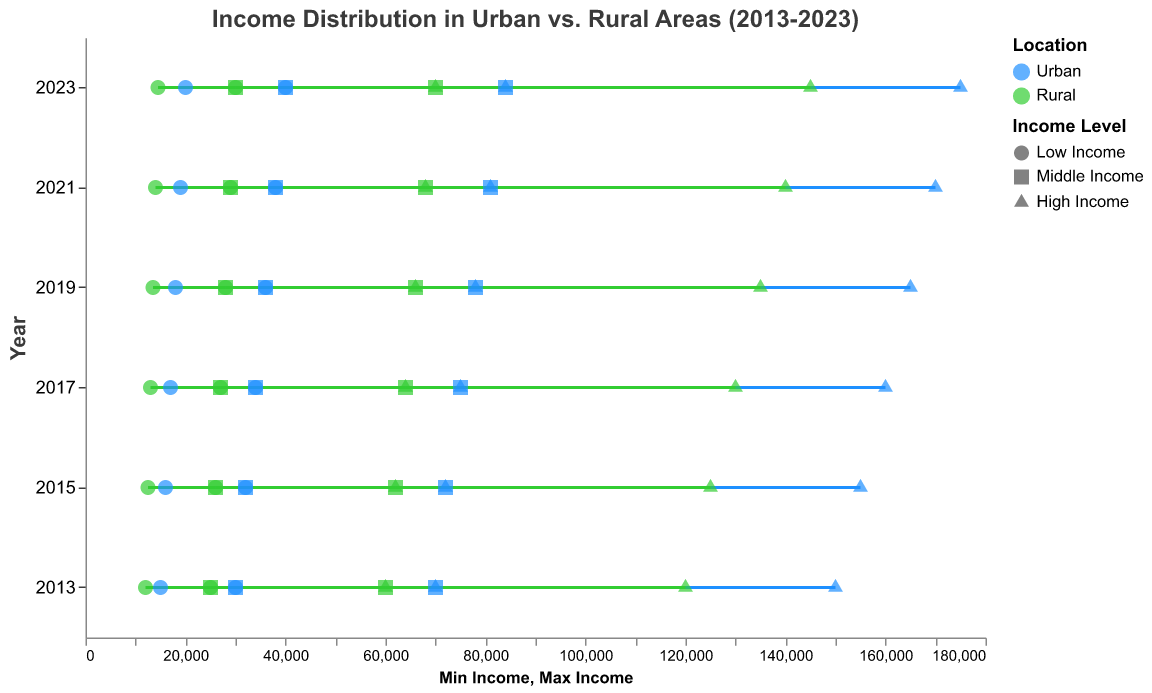What is the title of the figure? The title is located at the top of the chart in a slightly larger font size and reads "Income Distribution in Urban vs. Rural Areas (2013-2023)"
Answer: Income Distribution in Urban vs. Rural Areas (2013-2023) How many years of data are displayed in the figure? Count the distinct years labeled on the vertical axis of the plot, which orders the years in descending order from 2023 to 2013
Answer: 6 For the year 2023, what are the minimum and maximum incomes for the high-income rural area? Locate the year 2023 on the vertical axis, then find the corresponding high-income rural data point. The high-income rural data points are represented by triangles and colored in green. The range is marked by two points on the horizontal axis.
Answer: 70,001 to 145,000 Which location, urban or rural, has a higher maximum income across all years? Compare the maximum income values represented as dots on the far right of the plot. Check both urban (blue) and rural (green) dots in high-income categories.
Answer: Urban How does the income range for middle-income urban areas change from 2013 to 2023? Observe the blue square points at the beginning of each year, detailing the range's minimum and maximum incomes.
Answer: Increases from 30,001-70,000 to 40,001-84,000 Which has a greater increase over time for middle-income levels, urban or rural areas? For each year, identify the income range for middle-income levels in both urban (blue square) and rural (green square). Measure the difference in min and max values from 2013 to 2023 for both locations. Urban: (84,000 - 70,000) = 14,000. Rural: (70,000 - 60,000) = 10,000
Answer: Urban What is the trend in min and max incomes for low-income urban areas from 2013 to 2023? Observe the blue circle points for low-income urban across each year, from 2013 to 2023. Note the changes in min and max values annually.
Answer: Both min and max incomes are increasing In 2021, what is the min income difference between urban and rural areas for high-income levels? For the year 2021, locate the high-income levels (triangle shapes) for both urban (blue) and rural (green). Subtract the min rural income from the min urban income. 81,001 (Urban) - 68,001 (Rural) = 13,000
Answer: 13,000 What shape represents the middle-income level in urban areas? Look at the legend to find what shape (circle, square, triangle) is used for different income levels. Identify the shape used for middle-income level in the urban category (blue color).
Answer: Square Is the income gap between urban and rural high-income levels widening or narrowing over the years? Describe the trend. Compare the difference between the maximum incomes of high-income rural and urban areas across the years from 2013 to 2023. Determine if this gap is increasing or decreasing. In 2013, the difference is (150,000 - 120,000) = 30,000, and in 2023, it is (175,000 - 145,000) = 30,000.
Answer: Constant 